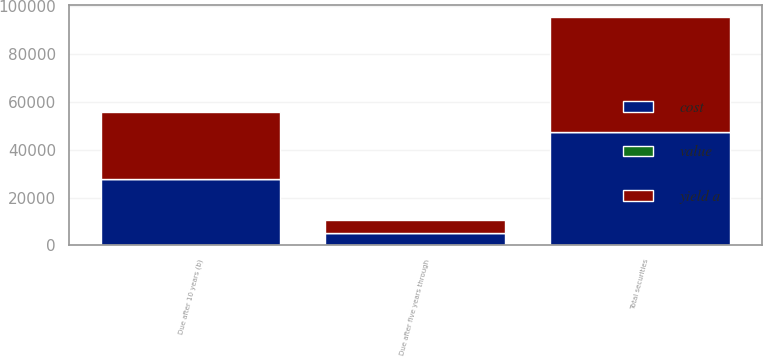<chart> <loc_0><loc_0><loc_500><loc_500><stacked_bar_chart><ecel><fcel>Due after five years through<fcel>Due after 10 years (b)<fcel>Total securities<nl><fcel>yield a<fcel>5346<fcel>28184<fcel>47993<nl><fcel>cost<fcel>5366<fcel>27722<fcel>47523<nl><fcel>value<fcel>4.7<fcel>4.69<fcel>4.27<nl></chart> 